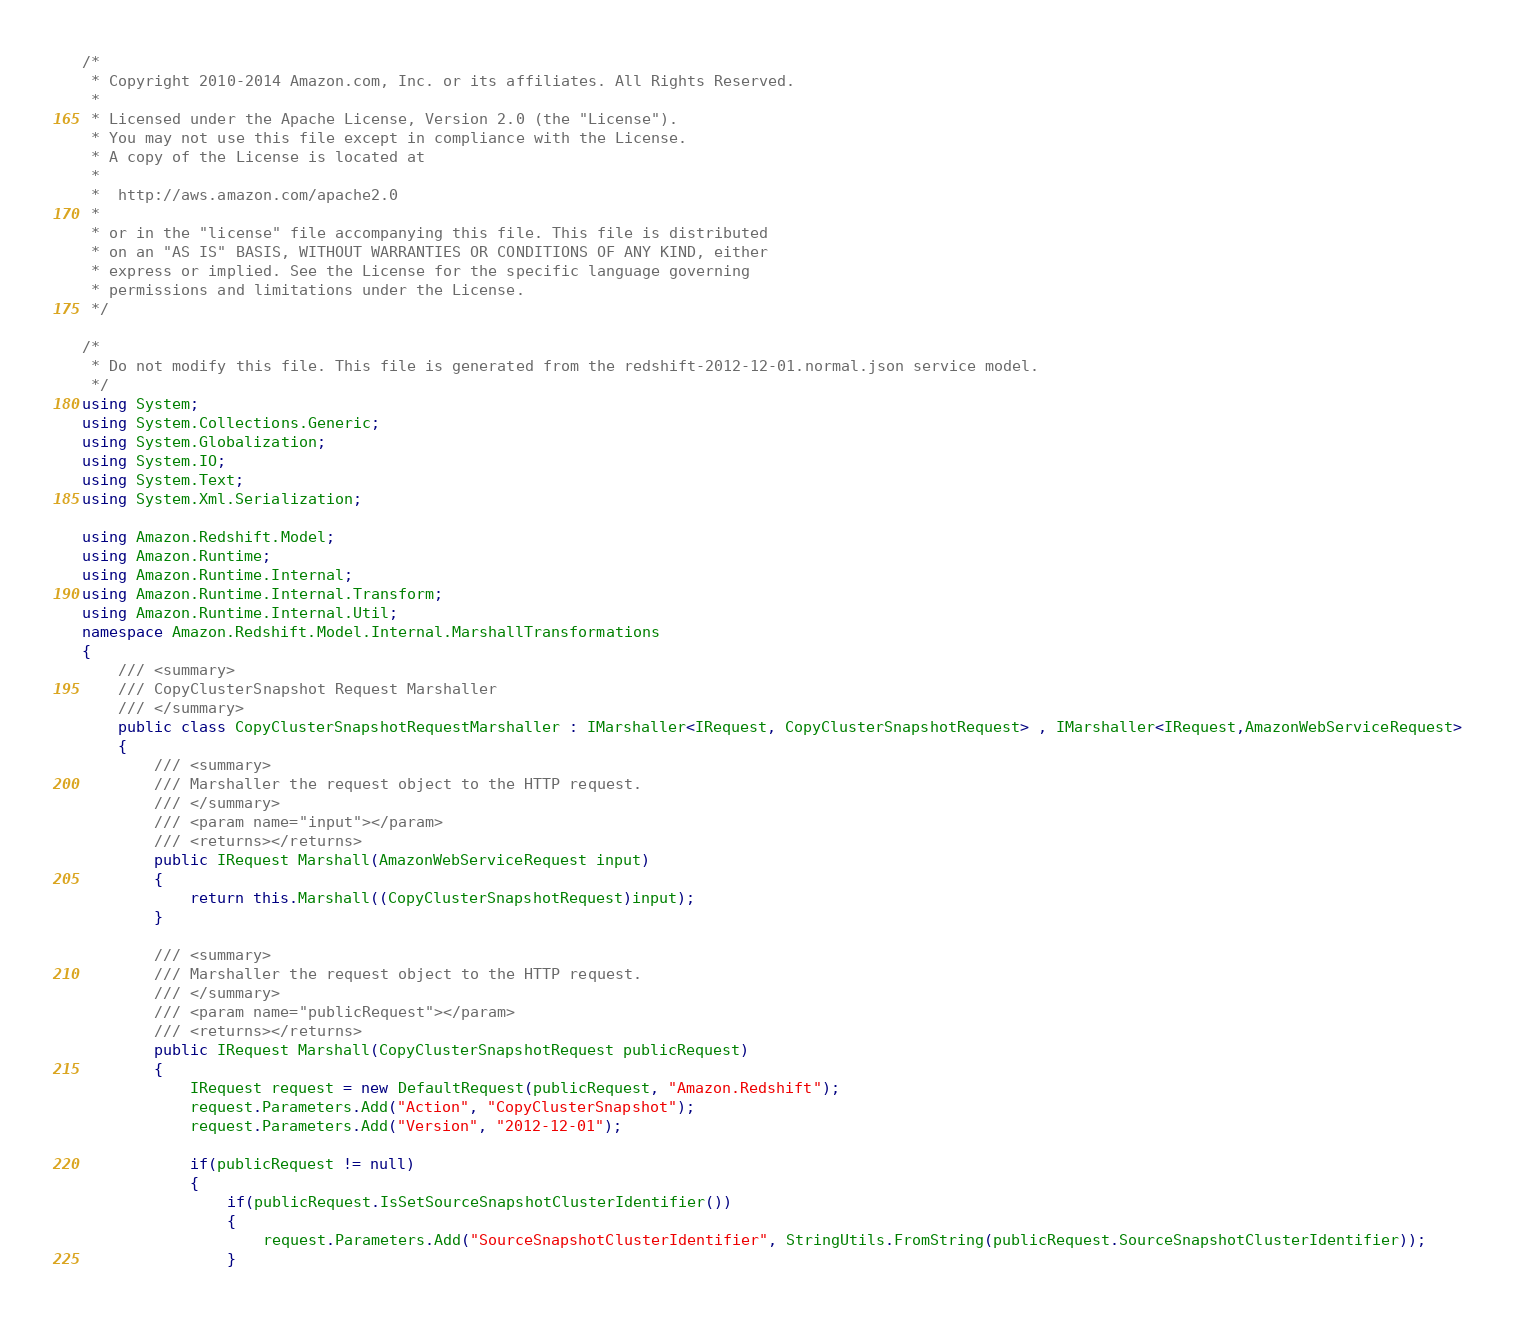Convert code to text. <code><loc_0><loc_0><loc_500><loc_500><_C#_>/*
 * Copyright 2010-2014 Amazon.com, Inc. or its affiliates. All Rights Reserved.
 * 
 * Licensed under the Apache License, Version 2.0 (the "License").
 * You may not use this file except in compliance with the License.
 * A copy of the License is located at
 * 
 *  http://aws.amazon.com/apache2.0
 * 
 * or in the "license" file accompanying this file. This file is distributed
 * on an "AS IS" BASIS, WITHOUT WARRANTIES OR CONDITIONS OF ANY KIND, either
 * express or implied. See the License for the specific language governing
 * permissions and limitations under the License.
 */

/*
 * Do not modify this file. This file is generated from the redshift-2012-12-01.normal.json service model.
 */
using System;
using System.Collections.Generic;
using System.Globalization;
using System.IO;
using System.Text;
using System.Xml.Serialization;

using Amazon.Redshift.Model;
using Amazon.Runtime;
using Amazon.Runtime.Internal;
using Amazon.Runtime.Internal.Transform;
using Amazon.Runtime.Internal.Util;
namespace Amazon.Redshift.Model.Internal.MarshallTransformations
{
    /// <summary>
    /// CopyClusterSnapshot Request Marshaller
    /// </summary>       
    public class CopyClusterSnapshotRequestMarshaller : IMarshaller<IRequest, CopyClusterSnapshotRequest> , IMarshaller<IRequest,AmazonWebServiceRequest>
    {
        /// <summary>
        /// Marshaller the request object to the HTTP request.
        /// </summary>  
        /// <param name="input"></param>
        /// <returns></returns>
        public IRequest Marshall(AmazonWebServiceRequest input)
        {
            return this.Marshall((CopyClusterSnapshotRequest)input);
        }
    
        /// <summary>
        /// Marshaller the request object to the HTTP request.
        /// </summary>  
        /// <param name="publicRequest"></param>
        /// <returns></returns>
        public IRequest Marshall(CopyClusterSnapshotRequest publicRequest)
        {
            IRequest request = new DefaultRequest(publicRequest, "Amazon.Redshift");
            request.Parameters.Add("Action", "CopyClusterSnapshot");
            request.Parameters.Add("Version", "2012-12-01");

            if(publicRequest != null)
            {
                if(publicRequest.IsSetSourceSnapshotClusterIdentifier())
                {
                    request.Parameters.Add("SourceSnapshotClusterIdentifier", StringUtils.FromString(publicRequest.SourceSnapshotClusterIdentifier));
                }</code> 